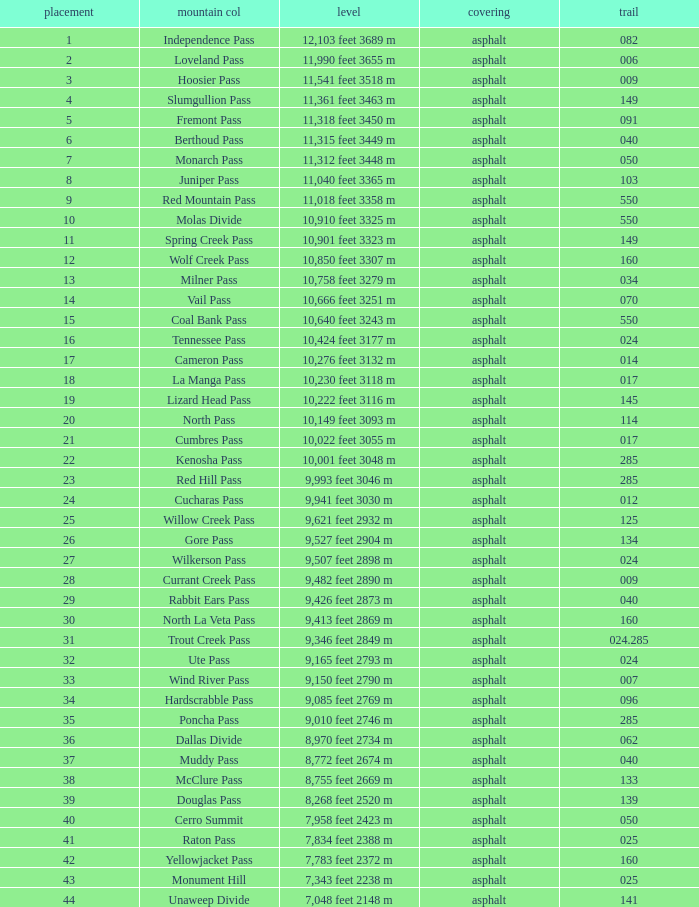On what Route is the mountain with a Rank less than 33 and an Elevation of 11,312 feet 3448 m? 50.0. 